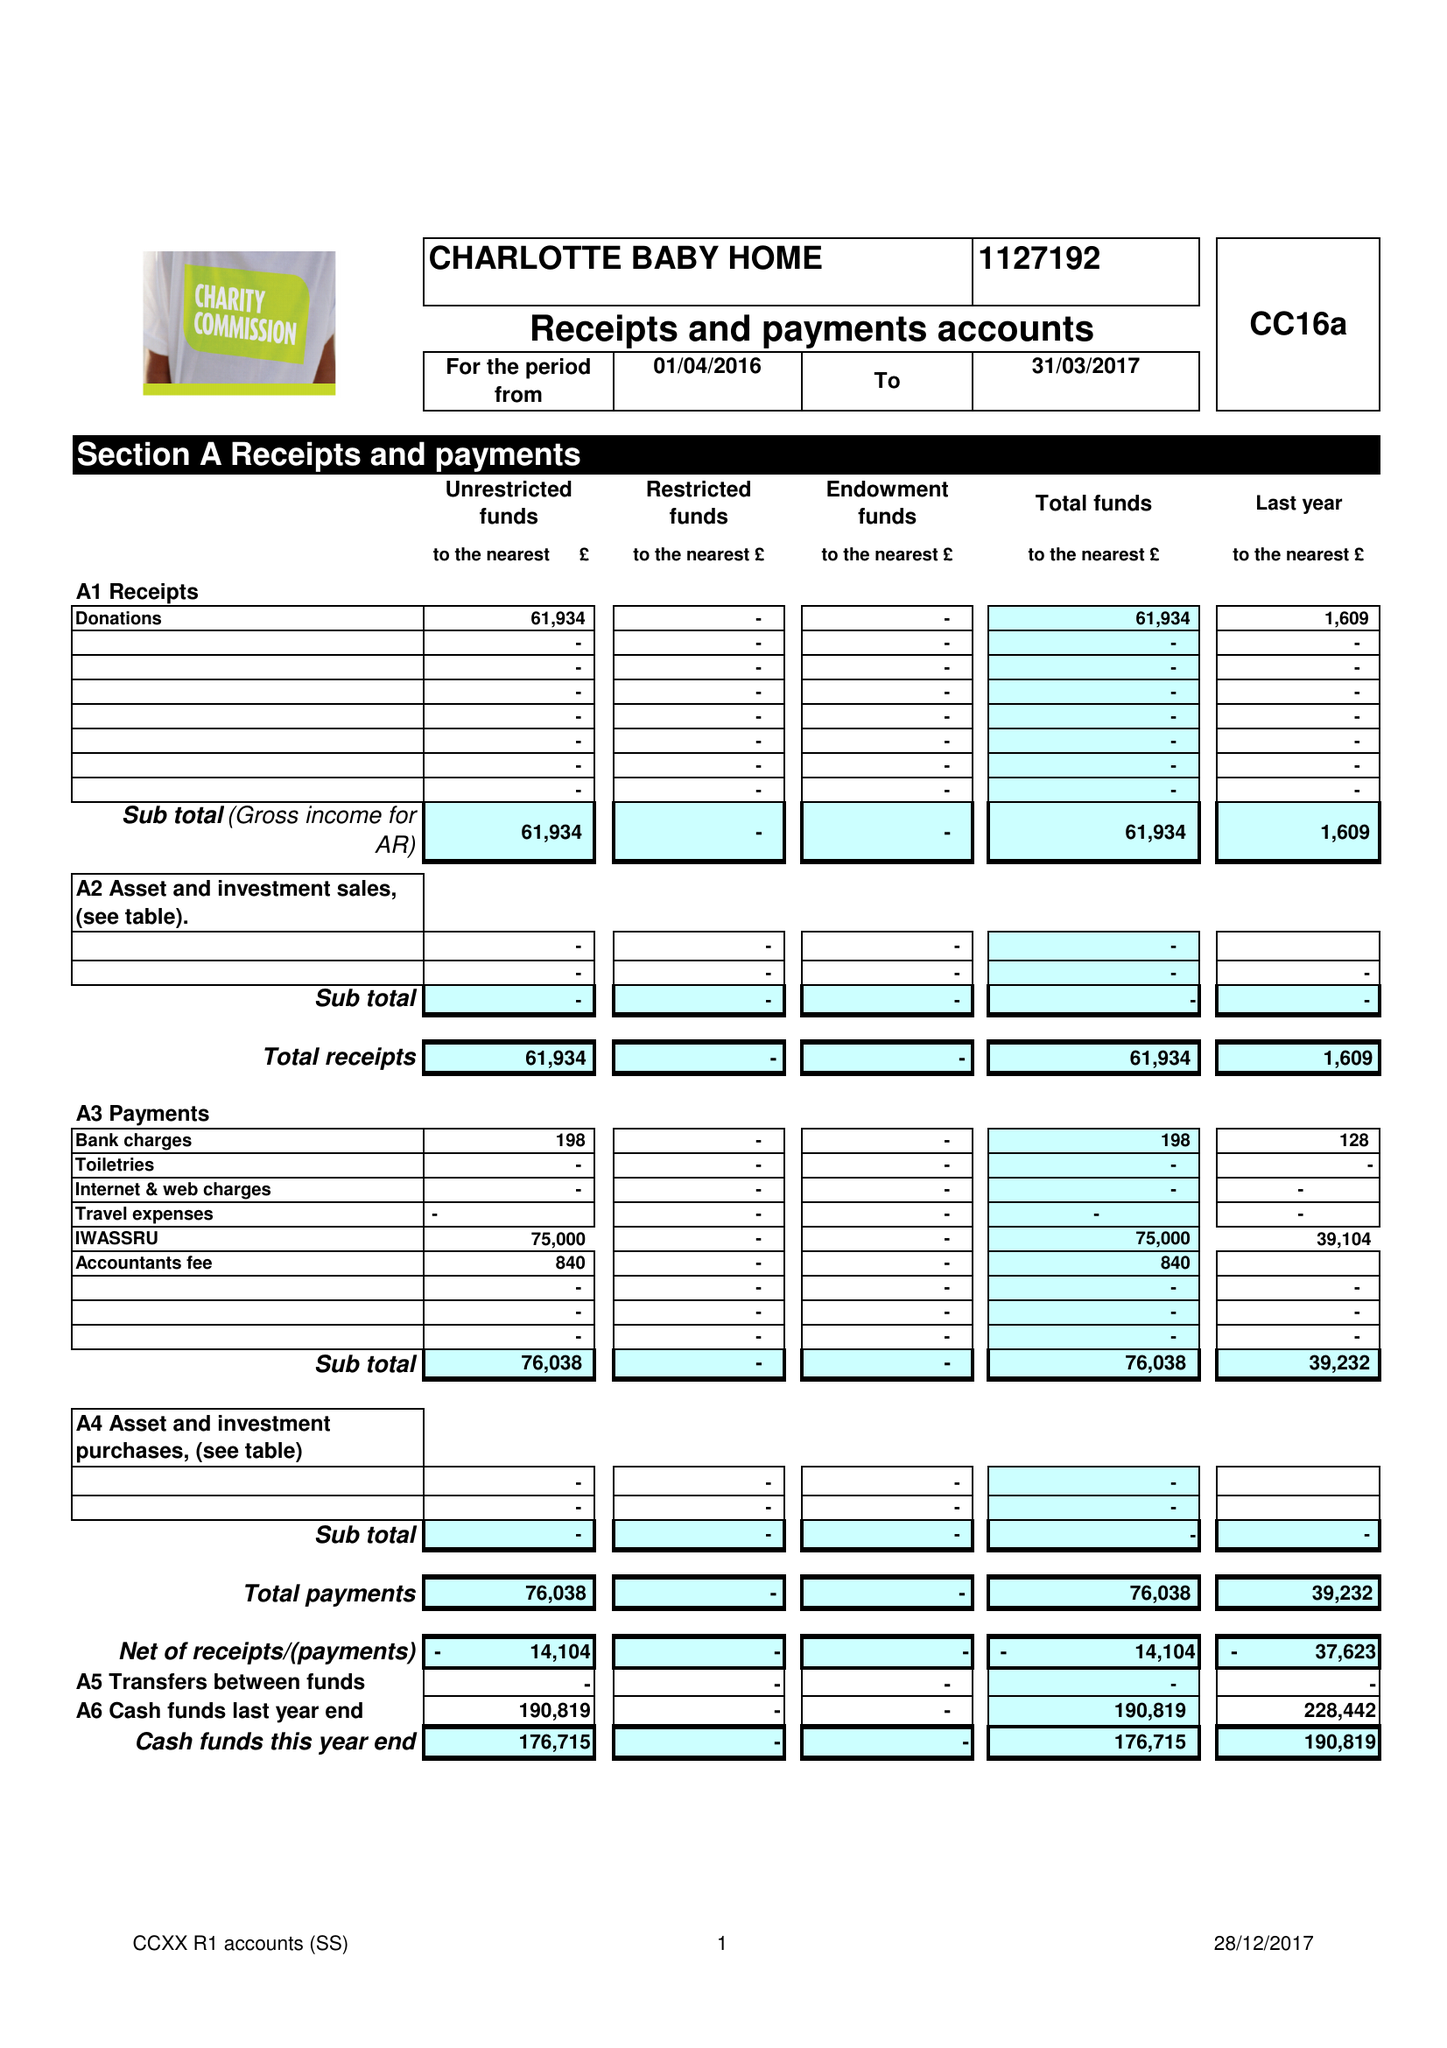What is the value for the charity_number?
Answer the question using a single word or phrase. 1127192 